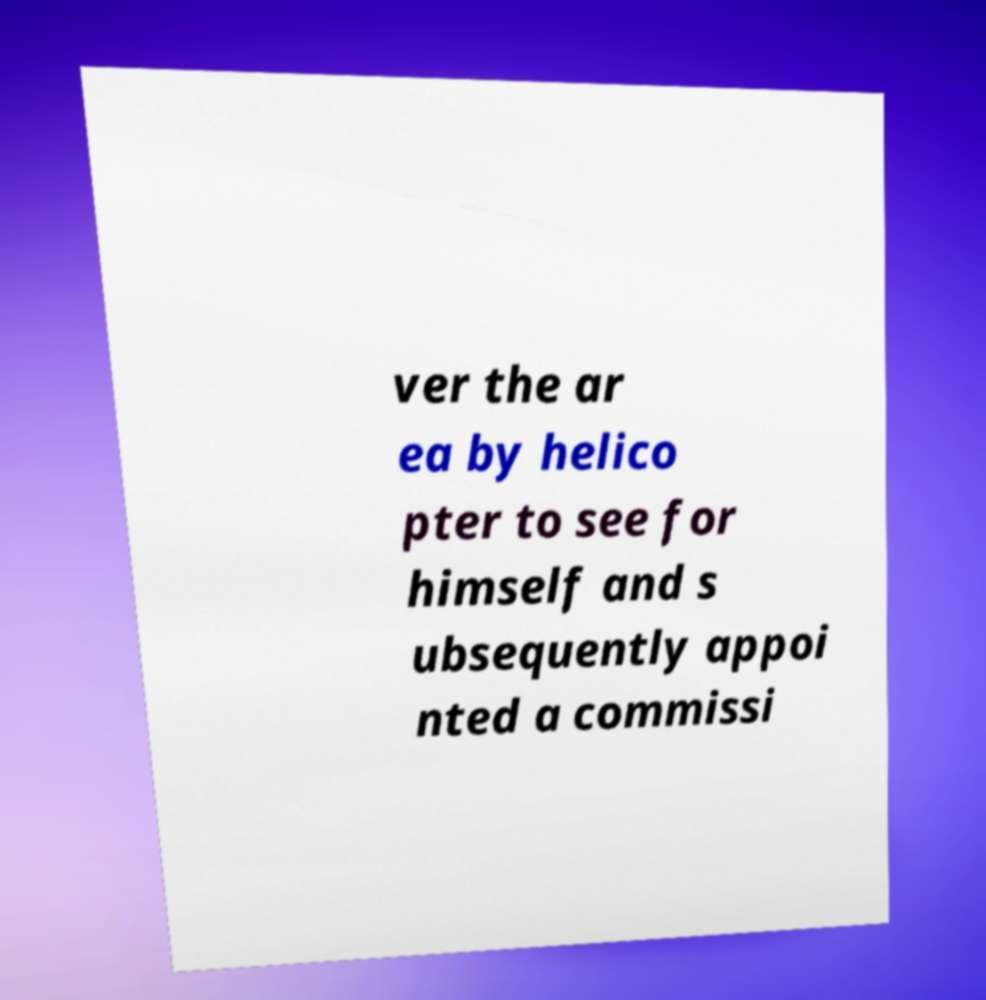Please read and relay the text visible in this image. What does it say? ver the ar ea by helico pter to see for himself and s ubsequently appoi nted a commissi 